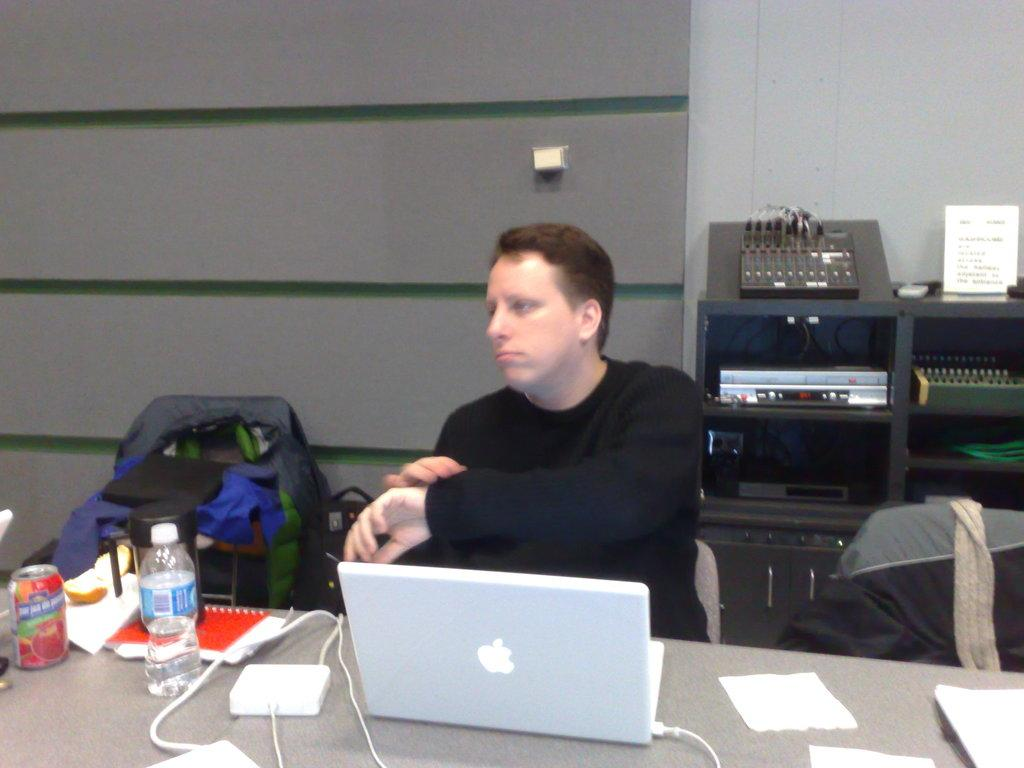What is the man in the image doing? The man is sitting behind a table in the image. What objects can be seen on the table? There is a laptop, a book, and wires on the table. What is located at the back of the image? There is a device at the back of the image. Where is the bag in the image? The bag is on the left side of the image. What type of toys are scattered around the table in the image? There are no toys present in the image; the objects on the table include a laptop, a book, and wires. 